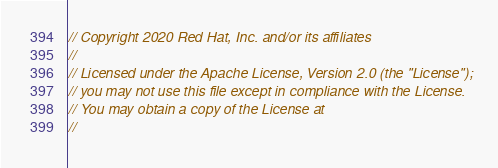Convert code to text. <code><loc_0><loc_0><loc_500><loc_500><_Go_>// Copyright 2020 Red Hat, Inc. and/or its affiliates
//
// Licensed under the Apache License, Version 2.0 (the "License");
// you may not use this file except in compliance with the License.
// You may obtain a copy of the License at
//</code> 